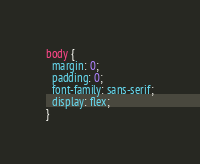Convert code to text. <code><loc_0><loc_0><loc_500><loc_500><_CSS_>body {
  margin: 0;
  padding: 0;
  font-family: sans-serif;
  display: flex;
}
</code> 